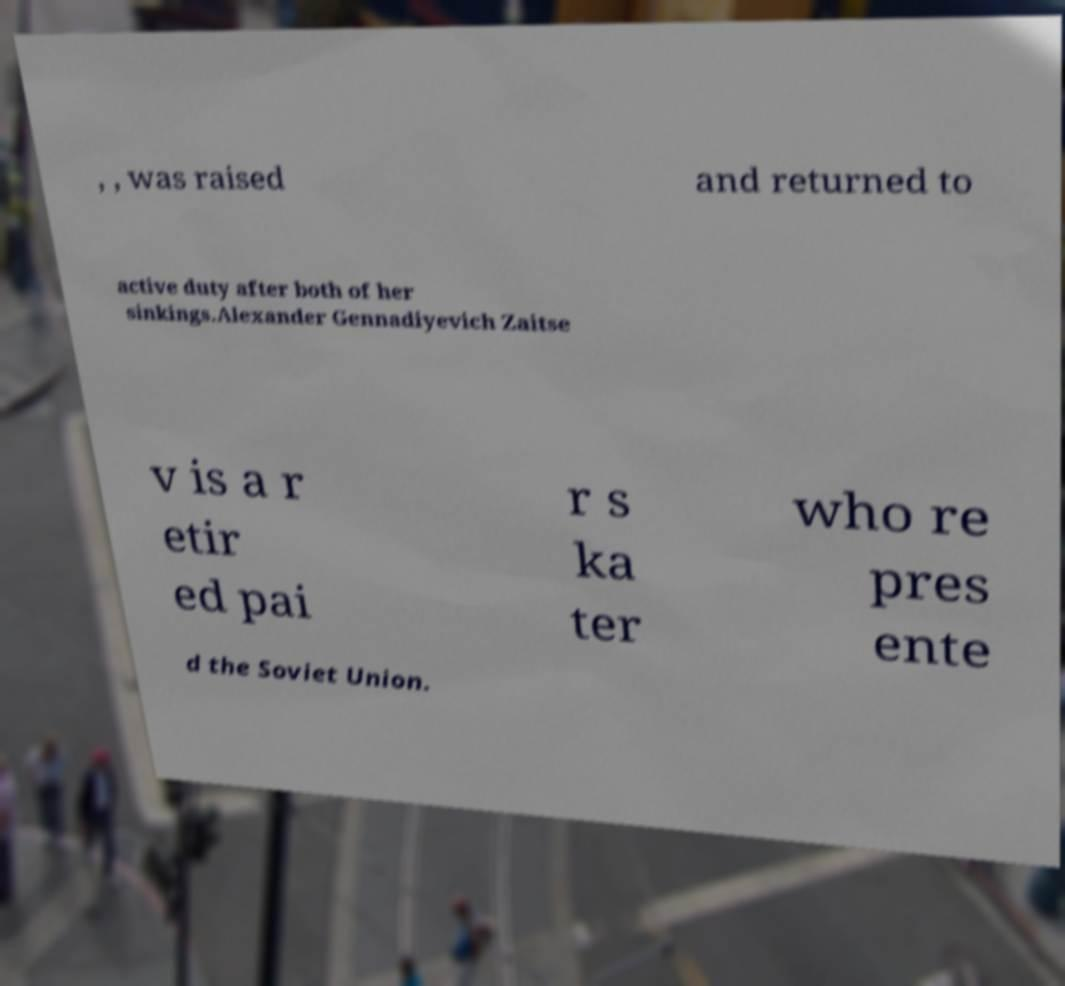I need the written content from this picture converted into text. Can you do that? , , was raised and returned to active duty after both of her sinkings.Alexander Gennadiyevich Zaitse v is a r etir ed pai r s ka ter who re pres ente d the Soviet Union. 